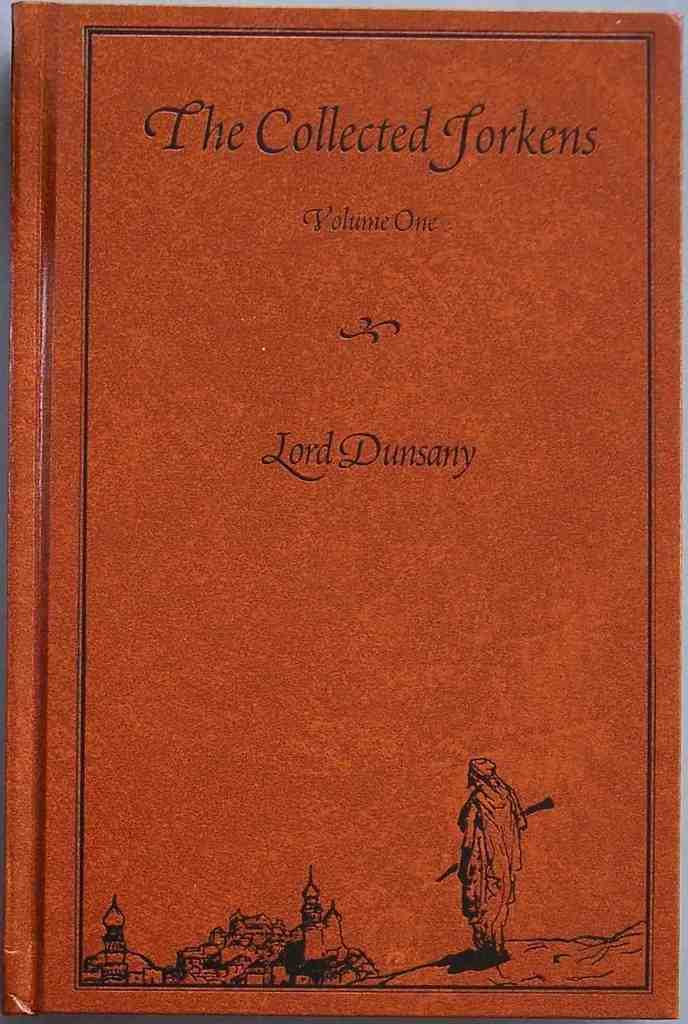Provide a one-sentence caption for the provided image. A red book titled the Collected Jorkens by Lord Dunsany. 